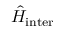<formula> <loc_0><loc_0><loc_500><loc_500>\hat { H } _ { i n t e r }</formula> 